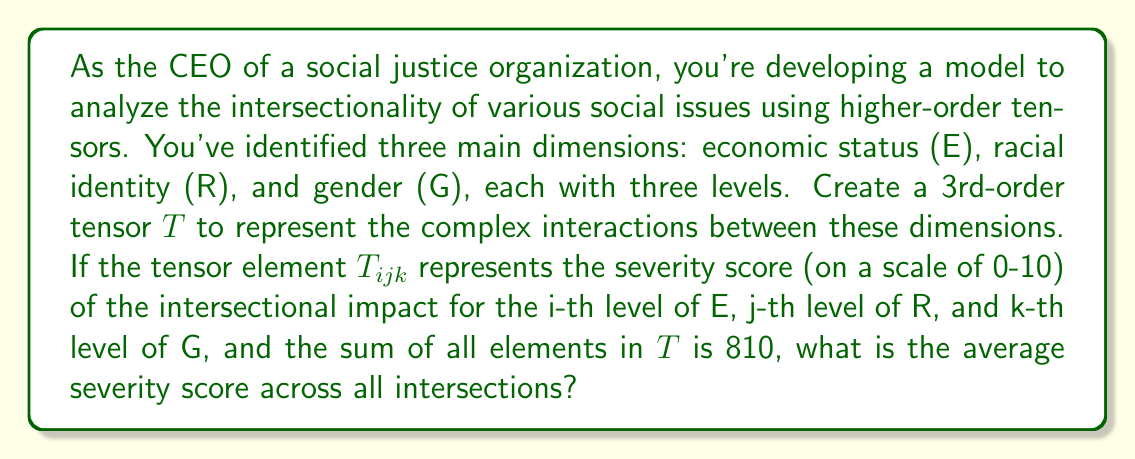Give your solution to this math problem. Let's approach this step-by-step:

1) First, we need to understand the structure of our tensor $T$. It's a 3rd-order tensor with dimensions 3 x 3 x 3, representing the three levels in each of the three dimensions (E, R, G).

2) The total number of elements in $T$ is therefore:
   $$ 3 \times 3 \times 3 = 27 $$

3) We're given that the sum of all elements in $T$ is 810. Let's call this sum $S$:
   $$ S = \sum_{i=1}^3 \sum_{j=1}^3 \sum_{k=1}^3 T_{ijk} = 810 $$

4) To find the average severity score, we need to divide the sum by the total number of elements:
   $$ \text{Average} = \frac{S}{\text{Number of elements}} = \frac{810}{27} $$

5) Calculating this:
   $$ \frac{810}{27} = 30 $$

Therefore, the average severity score across all intersections is 30.
Answer: 30 